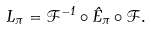<formula> <loc_0><loc_0><loc_500><loc_500>L _ { \pi } = \mathcal { F } ^ { - 1 } \circ \hat { E } _ { \pi } \circ \mathcal { F } .</formula> 